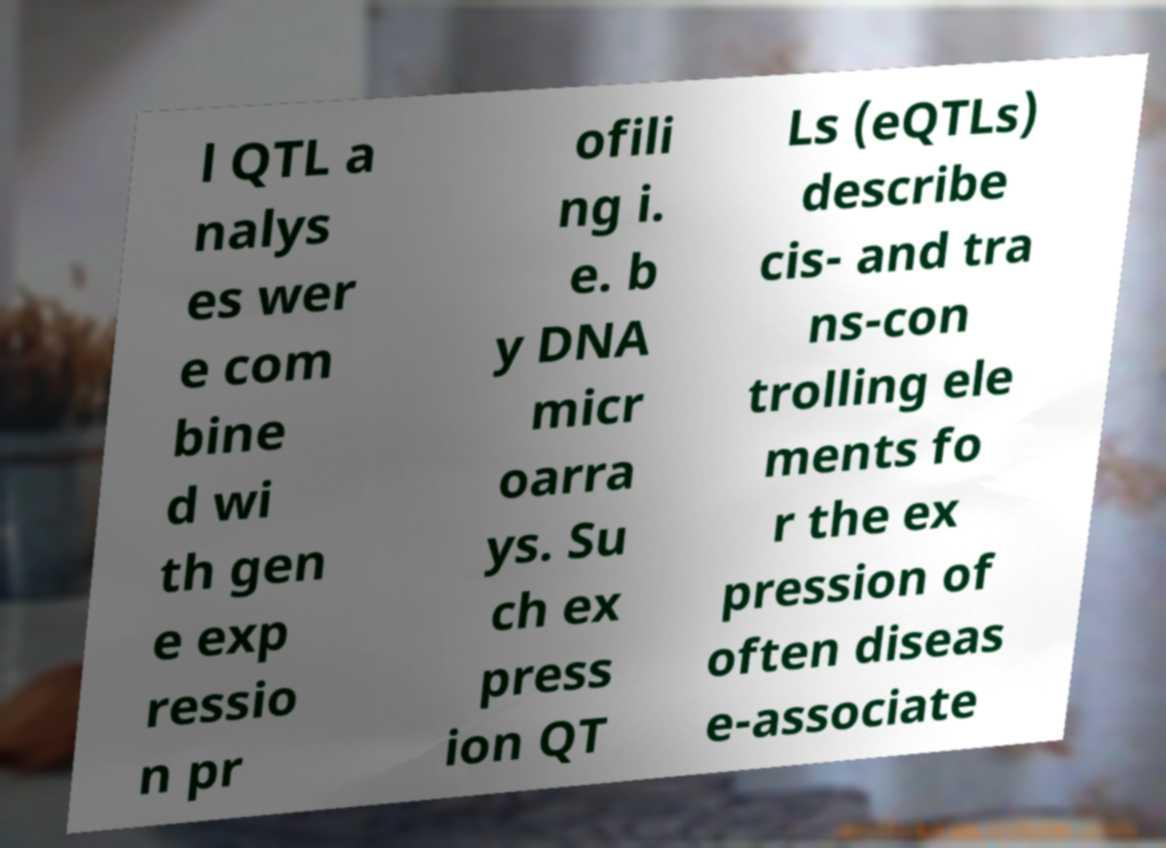Please identify and transcribe the text found in this image. l QTL a nalys es wer e com bine d wi th gen e exp ressio n pr ofili ng i. e. b y DNA micr oarra ys. Su ch ex press ion QT Ls (eQTLs) describe cis- and tra ns-con trolling ele ments fo r the ex pression of often diseas e-associate 